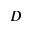<formula> <loc_0><loc_0><loc_500><loc_500>D</formula> 